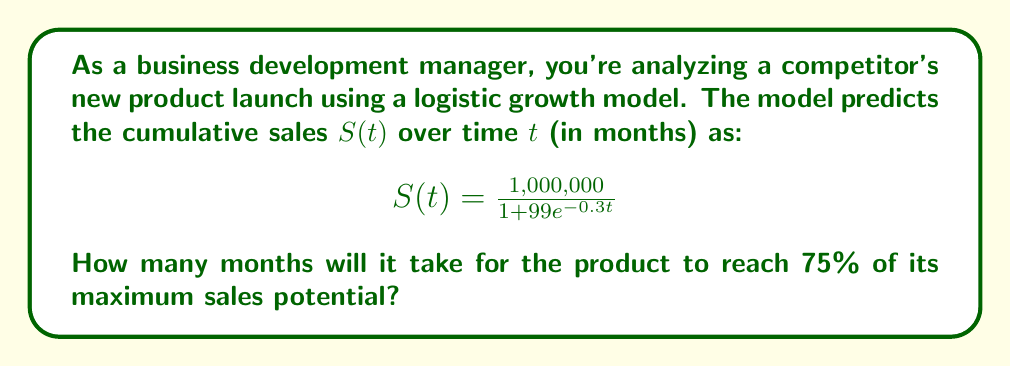What is the answer to this math problem? To solve this problem, we'll follow these steps:

1) First, identify the maximum sales potential. In the logistic growth model, this is the value that $S(t)$ approaches as $t$ goes to infinity. In this case, it's 1,000,000 units.

2) Calculate 75% of the maximum sales potential:
   $0.75 \times 1,000,000 = 750,000$ units

3) Set up the equation:
   $$750,000 = \frac{1,000,000}{1 + 99e^{-0.3t}}$$

4) Solve for $t$:
   
   $$750,000(1 + 99e^{-0.3t}) = 1,000,000$$
   $$750,000 + 74,250,000e^{-0.3t} = 1,000,000$$
   $$74,250,000e^{-0.3t} = 250,000$$
   $$e^{-0.3t} = \frac{250,000}{74,250,000} = \frac{1}{297}$$

5) Take the natural logarithm of both sides:
   $$-0.3t = \ln(\frac{1}{297})$$

6) Solve for $t$:
   $$t = -\frac{\ln(\frac{1}{297})}{0.3} = \frac{\ln(297)}{0.3} \approx 19.05$$

7) Since we're dealing with months, we round up to the nearest whole number.
Answer: 20 months 